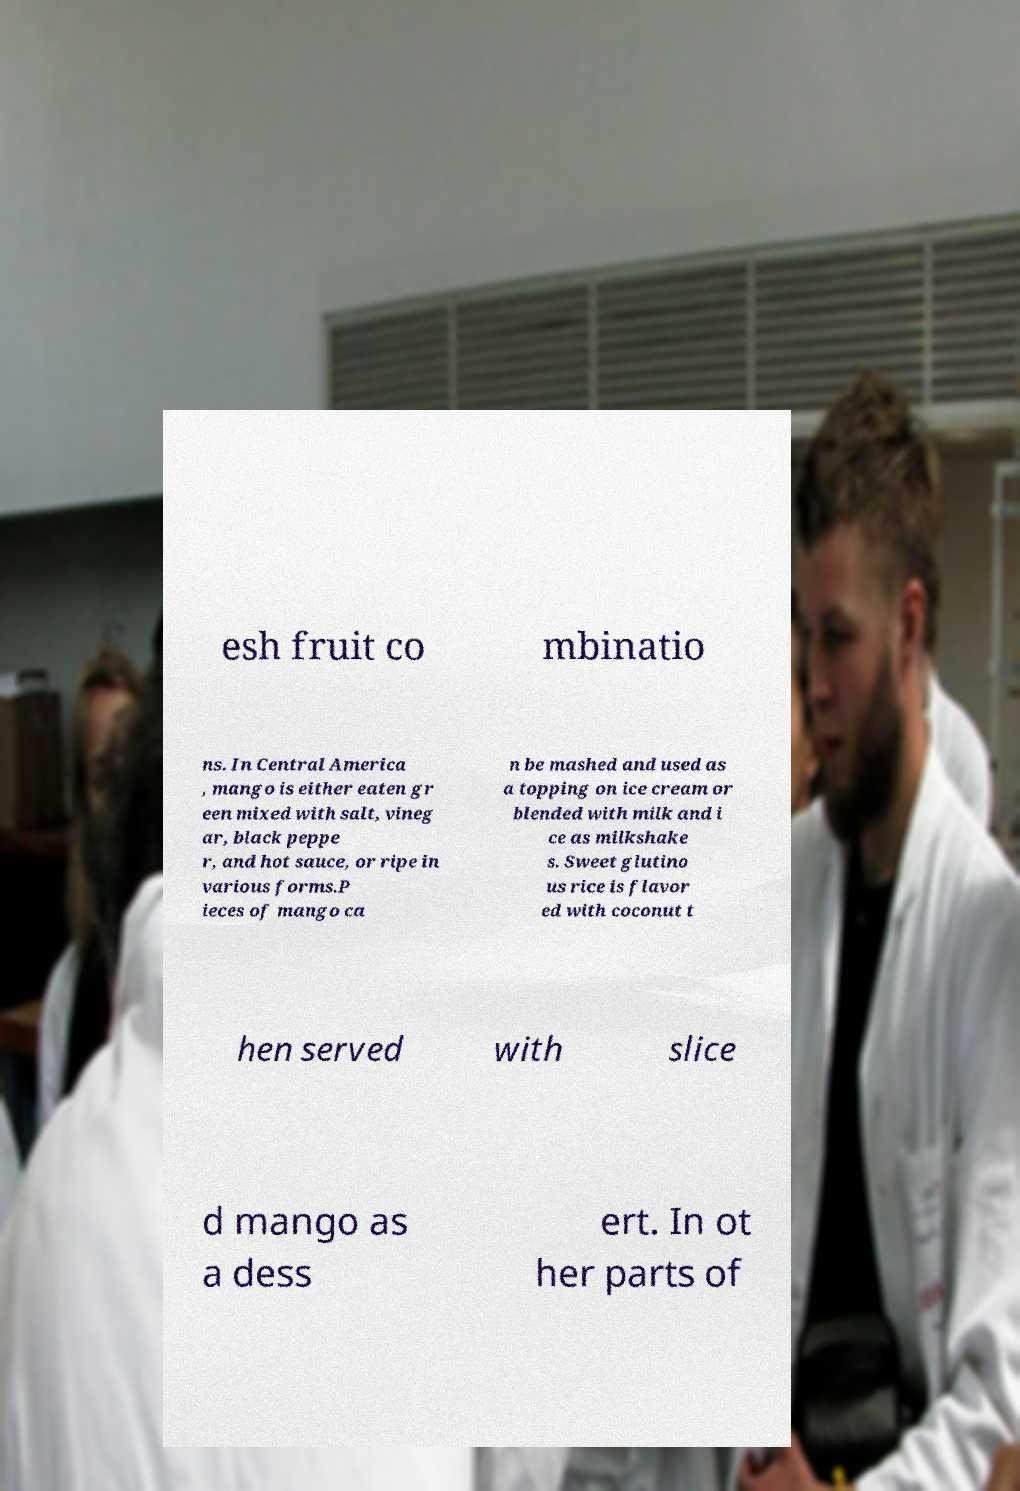What messages or text are displayed in this image? I need them in a readable, typed format. esh fruit co mbinatio ns. In Central America , mango is either eaten gr een mixed with salt, vineg ar, black peppe r, and hot sauce, or ripe in various forms.P ieces of mango ca n be mashed and used as a topping on ice cream or blended with milk and i ce as milkshake s. Sweet glutino us rice is flavor ed with coconut t hen served with slice d mango as a dess ert. In ot her parts of 